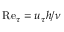Convert formula to latex. <formula><loc_0><loc_0><loc_500><loc_500>R e _ { \tau } = u _ { \tau } h / \nu</formula> 